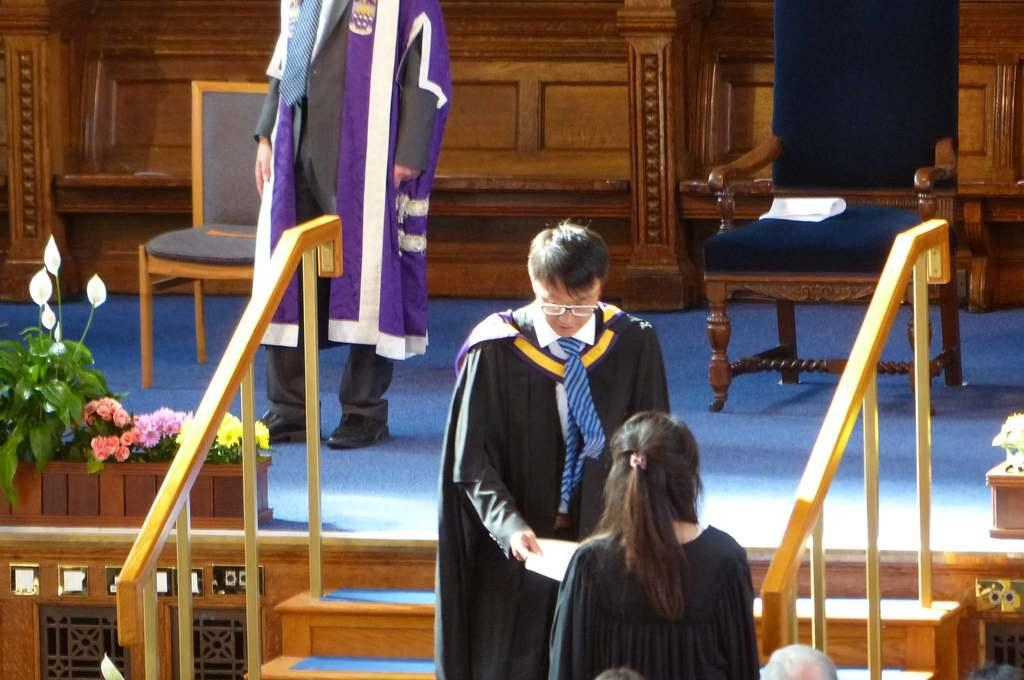What is happening on the stage in the image? There is a man on the stage. Are there any other people visible in the image? Yes, there are two people on the steps. What objects are present on the stage? Chairs and a houseplant are present on the stage. What type of reading material is the man holding on the stage? There is no reading material visible in the image; the man is not holding anything. How many rings are visible on the fingers of the people in the image? There are no rings visible on the fingers of the people in the image. 